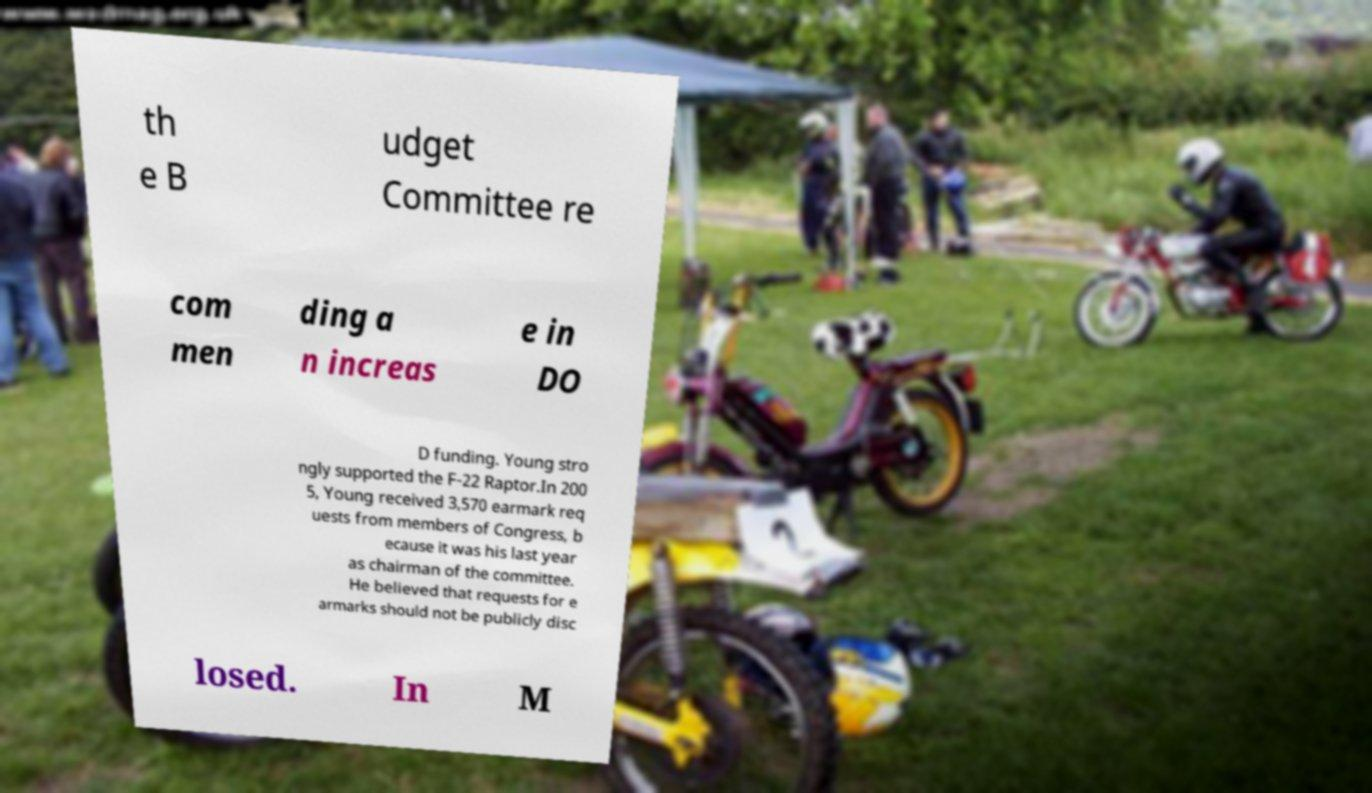I need the written content from this picture converted into text. Can you do that? th e B udget Committee re com men ding a n increas e in DO D funding. Young stro ngly supported the F-22 Raptor.In 200 5, Young received 3,570 earmark req uests from members of Congress, b ecause it was his last year as chairman of the committee. He believed that requests for e armarks should not be publicly disc losed. In M 